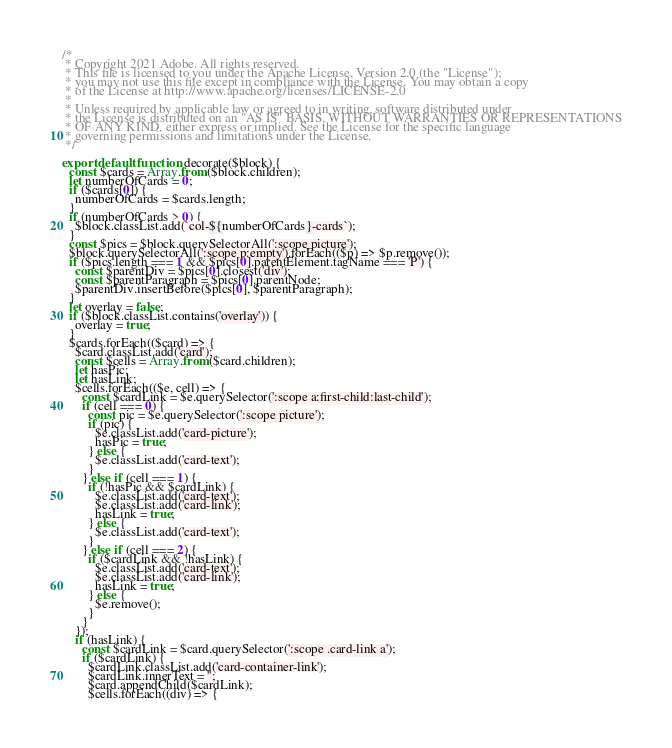<code> <loc_0><loc_0><loc_500><loc_500><_JavaScript_>/*
 * Copyright 2021 Adobe. All rights reserved.
 * This file is licensed to you under the Apache License, Version 2.0 (the "License");
 * you may not use this file except in compliance with the License. You may obtain a copy
 * of the License at http://www.apache.org/licenses/LICENSE-2.0
 *
 * Unless required by applicable law or agreed to in writing, software distributed under
 * the License is distributed on an "AS IS" BASIS, WITHOUT WARRANTIES OR REPRESENTATIONS
 * OF ANY KIND, either express or implied. See the License for the specific language
 * governing permissions and limitations under the License.
 */

export default function decorate($block) {
  const $cards = Array.from($block.children);
  let numberOfCards = 0;
  if ($cards[0]) {
    numberOfCards = $cards.length;
  }
  if (numberOfCards > 0) {
    $block.classList.add(`col-${numberOfCards}-cards`);
  }
  const $pics = $block.querySelectorAll(':scope picture');
  $block.querySelectorAll(':scope p:empty').forEach(($p) => $p.remove());
  if ($pics.length === 1 && $pics[0].parentElement.tagName === 'P') {
    const $parentDiv = $pics[0].closest('div');
    const $parentParagraph = $pics[0].parentNode;
    $parentDiv.insertBefore($pics[0], $parentParagraph);
  }
  let overlay = false;
  if ($block.classList.contains('overlay')) {
    overlay = true;
  }
  $cards.forEach(($card) => {
    $card.classList.add('card');
    const $cells = Array.from($card.children);
    let hasPic;
    let hasLink;
    $cells.forEach(($e, cell) => {
      const $cardLink = $e.querySelector(':scope a:first-child:last-child');
      if (cell === 0) {
        const pic = $e.querySelector(':scope picture');
        if (pic) {
          $e.classList.add('card-picture');
          hasPic = true;
        } else {
          $e.classList.add('card-text');
        }
      } else if (cell === 1) {
        if (!hasPic && $cardLink) {
          $e.classList.add('card-text');
          $e.classList.add('card-link');
          hasLink = true;
        } else {
          $e.classList.add('card-text');
        }
      } else if (cell === 2) {
        if ($cardLink && !hasLink) {
          $e.classList.add('card-text');
          $e.classList.add('card-link');
          hasLink = true;
        } else {
          $e.remove();
        }
      }
    });
    if (hasLink) {
      const $cardLink = $card.querySelector(':scope .card-link a');
      if ($cardLink) {
        $cardLink.classList.add('card-container-link');
        $cardLink.innerText = '';
        $card.appendChild($cardLink);
        $cells.forEach((div) => {</code> 